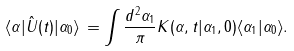<formula> <loc_0><loc_0><loc_500><loc_500>\langle \alpha | \hat { U } ( t ) | \alpha _ { 0 } \rangle \, = \int \frac { d ^ { 2 } \alpha _ { 1 } } { \pi } K ( \alpha , t | \alpha _ { 1 } , 0 ) \langle \alpha _ { 1 } | \alpha _ { 0 } \rangle .</formula> 